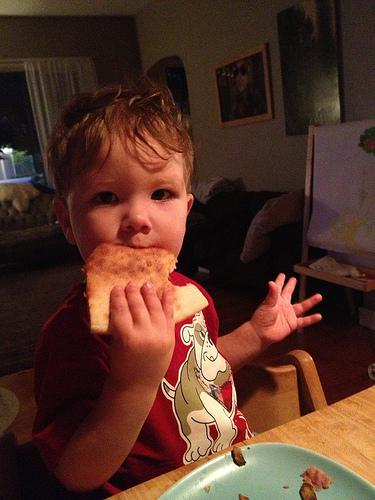Question: what is in his hand?
Choices:
A. Drink.
B. Food.
C. Ball.
D. Bat.
Answer with the letter. Answer: B Question: what hand holds the food?
Choices:
A. The left.
B. The one on the table.
C. Both.
D. Right hand.
Answer with the letter. Answer: D Question: where is an easel?
Choices:
A. In the art class.
B. To the boy's left.
C. Behind the teacher.
D. Next to the girl.
Answer with the letter. Answer: B 